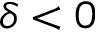Convert formula to latex. <formula><loc_0><loc_0><loc_500><loc_500>\delta < 0</formula> 